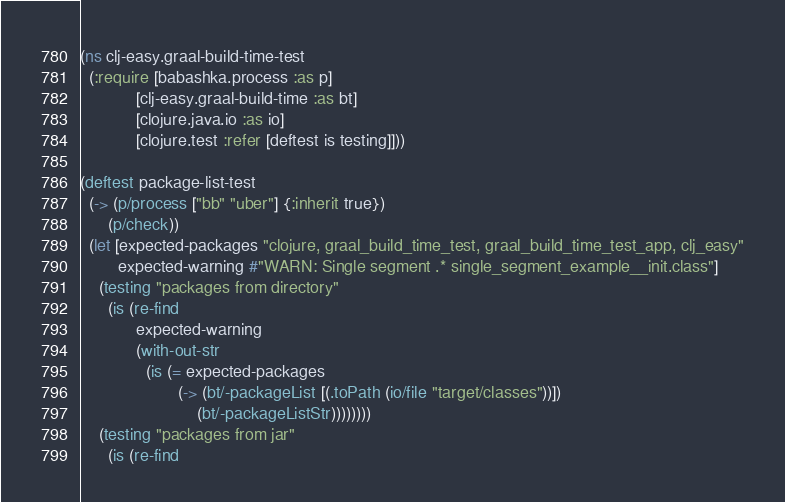<code> <loc_0><loc_0><loc_500><loc_500><_Clojure_>(ns clj-easy.graal-build-time-test
  (:require [babashka.process :as p]
            [clj-easy.graal-build-time :as bt]
            [clojure.java.io :as io]
            [clojure.test :refer [deftest is testing]]))

(deftest package-list-test
  (-> (p/process ["bb" "uber"] {:inherit true})
      (p/check))
  (let [expected-packages "clojure, graal_build_time_test, graal_build_time_test_app, clj_easy"
        expected-warning #"WARN: Single segment .* single_segment_example__init.class"]
    (testing "packages from directory"
      (is (re-find
            expected-warning
            (with-out-str
              (is (= expected-packages
                     (-> (bt/-packageList [(.toPath (io/file "target/classes"))])
                         (bt/-packageListStr))))))))
    (testing "packages from jar"
      (is (re-find</code> 